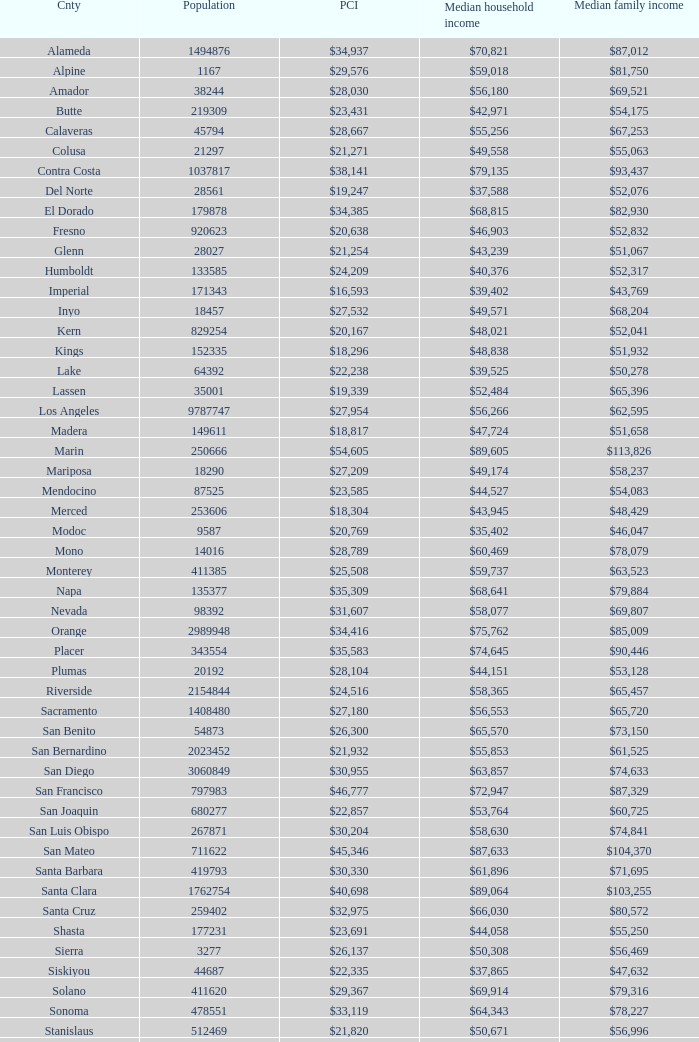Name the median family income for riverside $65,457. 